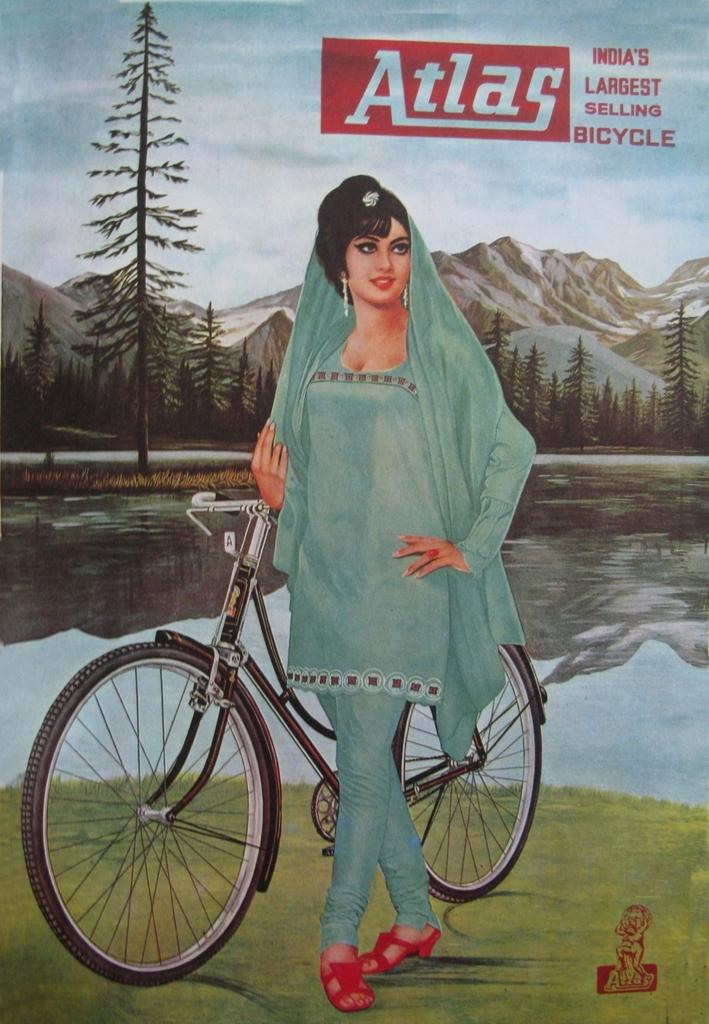What is featured on the poster in the image? There is a poster with text and an image in the image. What is the image on the poster depicting? The image on the poster depicts a woman standing near a bicycle on the ground. What can be seen in the background of the image? Water, trees, mountains, and the sky are visible in the background of the image. What type of creature is sitting on the girl's shoulder in the image? There is no girl present in the image; it features a poster with an image of a woman standing near a bicycle. How many needles are visible in the image? There are no needles present in the image. 